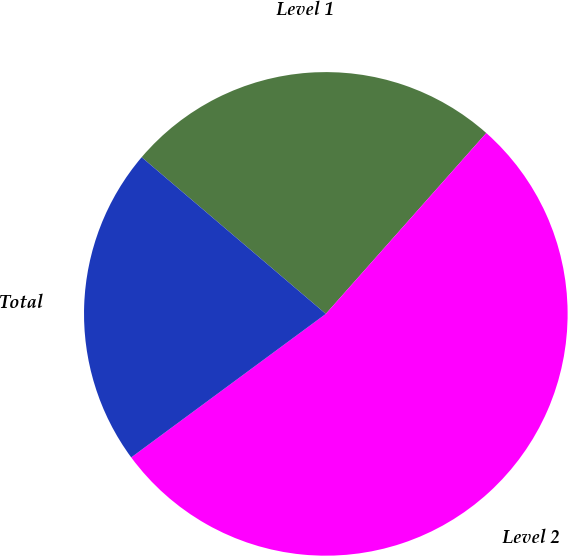Convert chart. <chart><loc_0><loc_0><loc_500><loc_500><pie_chart><fcel>Level 1<fcel>Level 2<fcel>Total<nl><fcel>25.33%<fcel>53.33%<fcel>21.33%<nl></chart> 